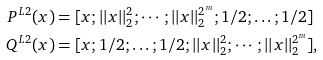<formula> <loc_0><loc_0><loc_500><loc_500>P ^ { L 2 } ( x ) & = [ x ; | | x | | ^ { 2 } _ { 2 } ; \cdots ; | | x | | ^ { 2 ^ { m } } _ { 2 } ; 1 / 2 ; \dots ; 1 / 2 ] \\ Q ^ { L 2 } ( x ) & = [ x ; 1 / 2 ; \dots ; 1 / 2 ; | | x | | ^ { 2 } _ { 2 } ; \cdots ; | | x | | ^ { 2 ^ { m } } _ { 2 } ] ,</formula> 